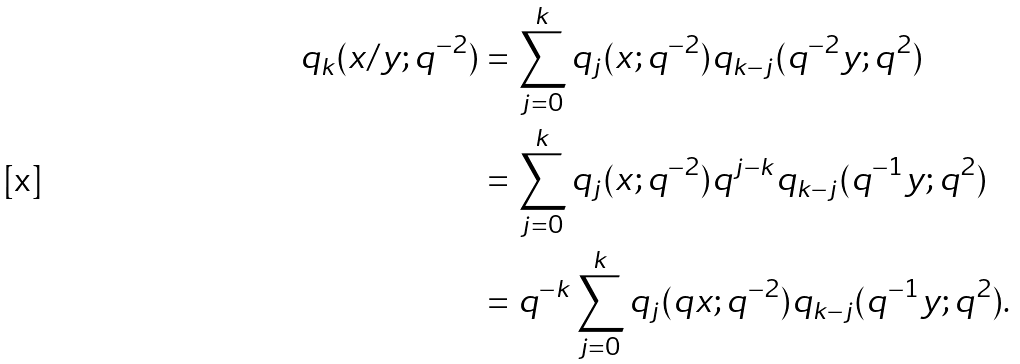<formula> <loc_0><loc_0><loc_500><loc_500>q _ { k } ( x / y ; q ^ { - 2 } ) & = \sum _ { j = 0 } ^ { k } q _ { j } ( x ; q ^ { - 2 } ) q _ { k - j } ( q ^ { - 2 } y ; q ^ { 2 } ) \\ & = \sum _ { j = 0 } ^ { k } q _ { j } ( x ; q ^ { - 2 } ) q ^ { j - k } q _ { k - j } ( q ^ { - 1 } y ; q ^ { 2 } ) \\ & = q ^ { - k } \sum _ { j = 0 } ^ { k } q _ { j } ( q x ; q ^ { - 2 } ) q _ { k - j } ( q ^ { - 1 } y ; q ^ { 2 } ) .</formula> 